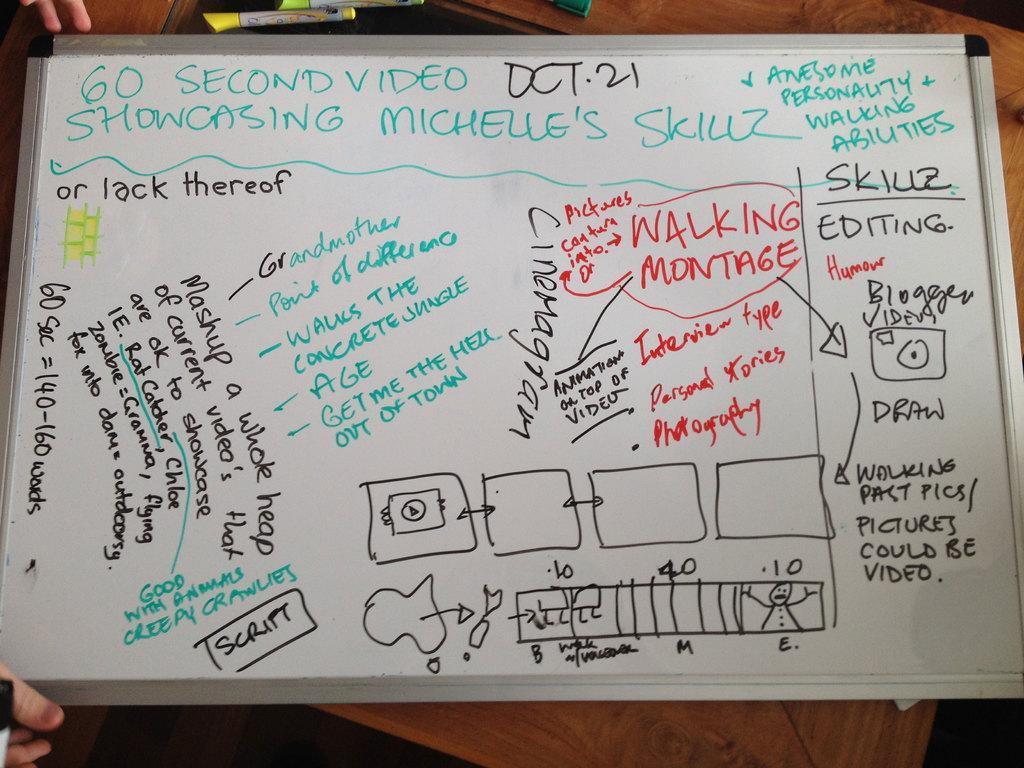Can you describe this image briefly? In this picture we can see the white board in the front with some drawings and matter on it. 